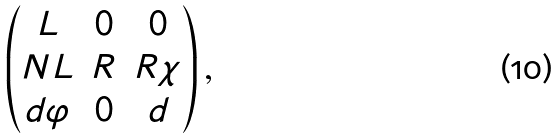Convert formula to latex. <formula><loc_0><loc_0><loc_500><loc_500>\begin{pmatrix} L & 0 & 0 \\ N L & R & R \chi \\ d \varphi & 0 & d \end{pmatrix} ,</formula> 